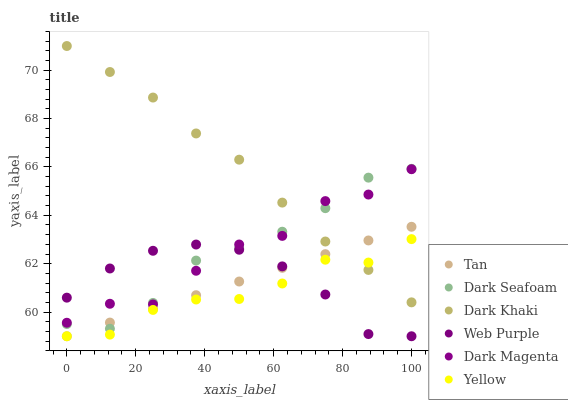Does Yellow have the minimum area under the curve?
Answer yes or no. Yes. Does Dark Khaki have the maximum area under the curve?
Answer yes or no. Yes. Does Dark Seafoam have the minimum area under the curve?
Answer yes or no. No. Does Dark Seafoam have the maximum area under the curve?
Answer yes or no. No. Is Tan the smoothest?
Answer yes or no. Yes. Is Dark Magenta the roughest?
Answer yes or no. Yes. Is Dark Seafoam the smoothest?
Answer yes or no. No. Is Dark Seafoam the roughest?
Answer yes or no. No. Does Yellow have the lowest value?
Answer yes or no. Yes. Does Dark Seafoam have the lowest value?
Answer yes or no. No. Does Dark Khaki have the highest value?
Answer yes or no. Yes. Does Dark Seafoam have the highest value?
Answer yes or no. No. Is Tan less than Dark Magenta?
Answer yes or no. Yes. Is Dark Magenta greater than Tan?
Answer yes or no. Yes. Does Yellow intersect Dark Khaki?
Answer yes or no. Yes. Is Yellow less than Dark Khaki?
Answer yes or no. No. Is Yellow greater than Dark Khaki?
Answer yes or no. No. Does Tan intersect Dark Magenta?
Answer yes or no. No. 